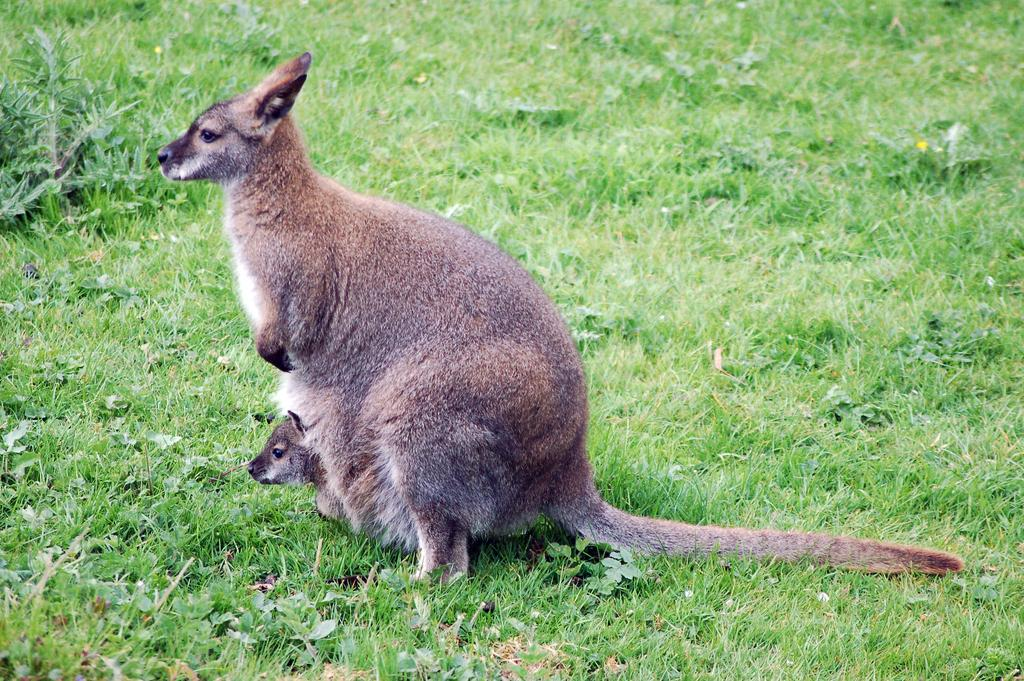What animal is the main subject of the image? There is a kangaroo in the image. What is the kangaroo doing in the image? The kangaroo is sitting on the ground. Does the kangaroo have any companions in the image? Yes, the kangaroo has a baby with it. What type of vegetation can be seen on the ground in the image? There are small plants and grass on the ground. How does the kangaroo use the stamp to wash the baby in the image? There is no stamp or washing activity depicted in the image; the kangaroo is simply sitting on the ground with its baby. What type of object is used to crush the small plants in the image? There is no object used to crush the small plants in the image; they are simply present on the ground. 